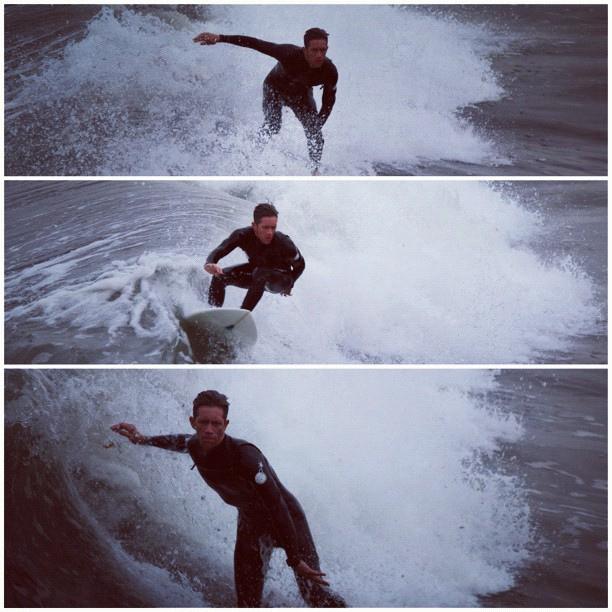What color are the waves?
Give a very brief answer. White. Are all 3 of these images of the same surfer?
Answer briefly. Yes. Is the surfer wearing a bodysuit?
Be succinct. Yes. 